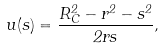Convert formula to latex. <formula><loc_0><loc_0><loc_500><loc_500>u ( s ) = \frac { R _ { C } ^ { 2 } - r ^ { 2 } - s ^ { 2 } } { 2 r s } ,</formula> 